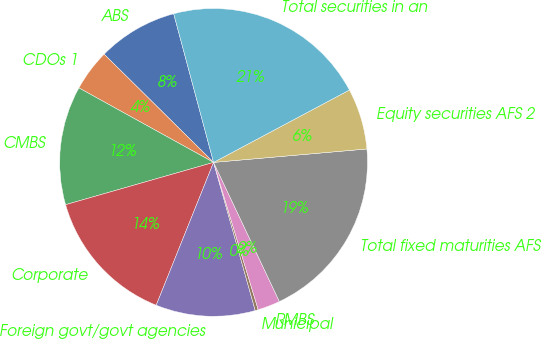<chart> <loc_0><loc_0><loc_500><loc_500><pie_chart><fcel>ABS<fcel>CDOs 1<fcel>CMBS<fcel>Corporate<fcel>Foreign govt/govt agencies<fcel>Municipal<fcel>RMBS<fcel>Total fixed maturities AFS<fcel>Equity securities AFS 2<fcel>Total securities in an<nl><fcel>8.42%<fcel>4.37%<fcel>12.47%<fcel>14.49%<fcel>10.44%<fcel>0.32%<fcel>2.35%<fcel>19.36%<fcel>6.4%<fcel>21.38%<nl></chart> 